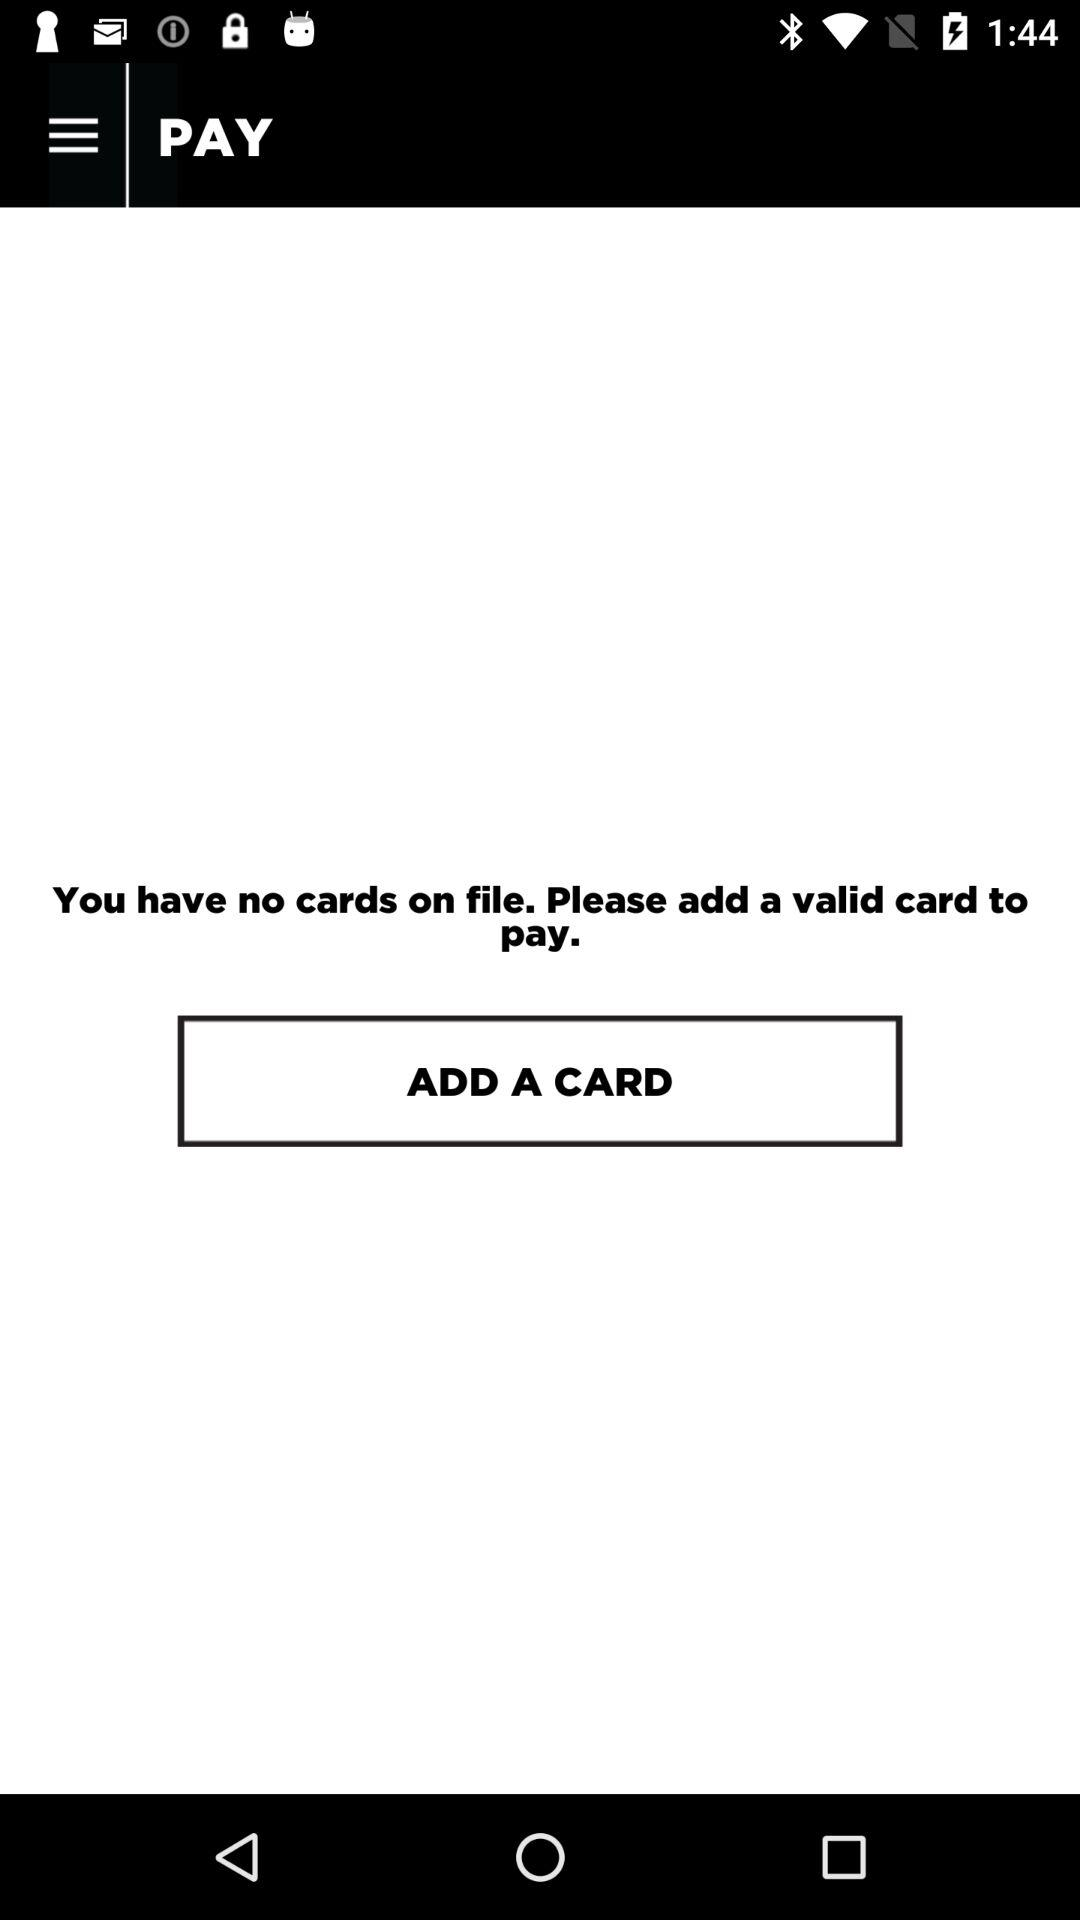Are there any cards on file? There are no cards on file. 